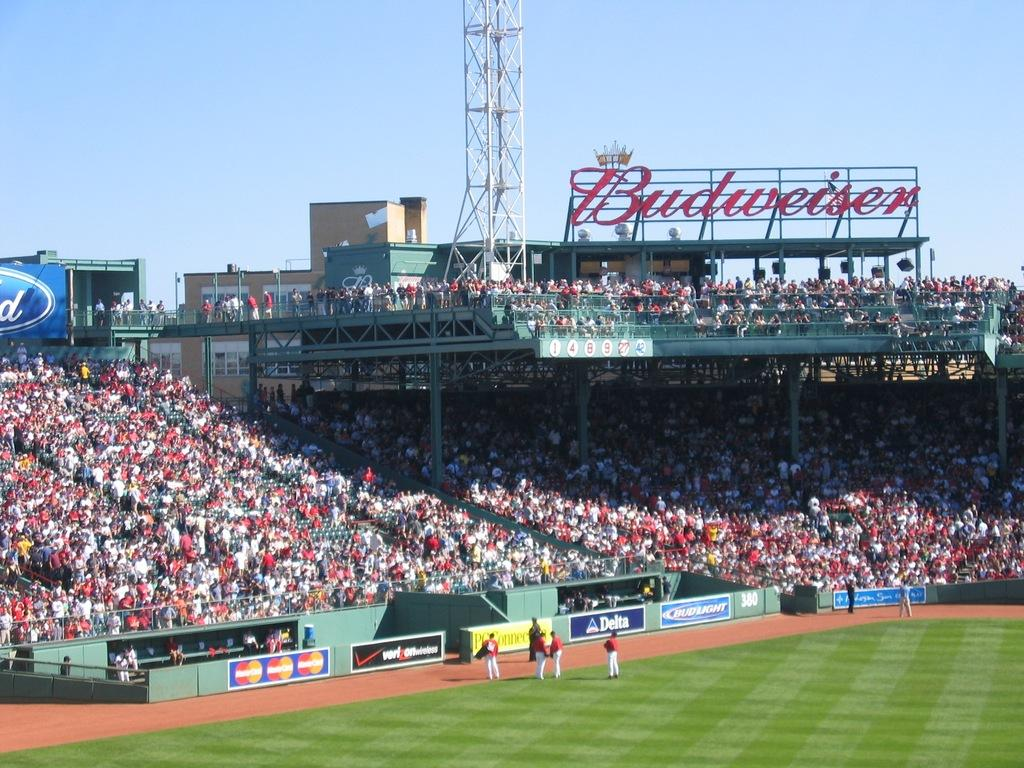<image>
Present a compact description of the photo's key features. The stands are packed at a baseball stadium under a large billboard for Budweiser. 